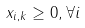<formula> <loc_0><loc_0><loc_500><loc_500>x _ { i , k } \geq 0 , \forall i</formula> 